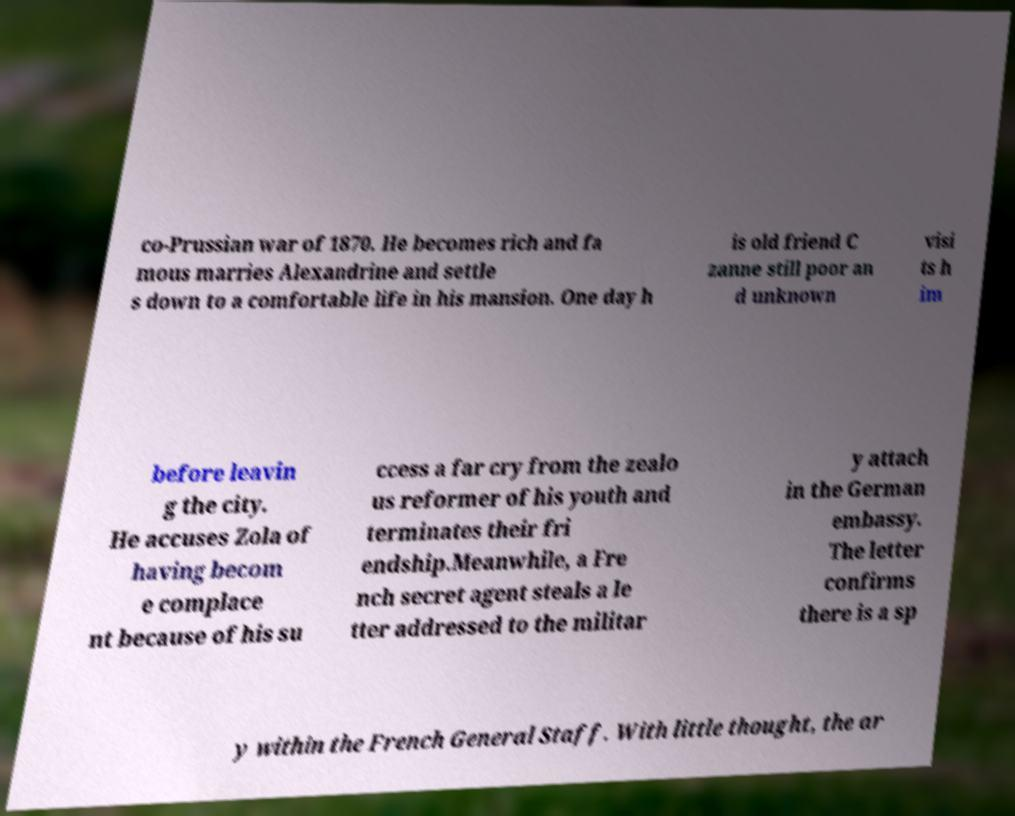Can you read and provide the text displayed in the image?This photo seems to have some interesting text. Can you extract and type it out for me? co-Prussian war of 1870. He becomes rich and fa mous marries Alexandrine and settle s down to a comfortable life in his mansion. One day h is old friend C zanne still poor an d unknown visi ts h im before leavin g the city. He accuses Zola of having becom e complace nt because of his su ccess a far cry from the zealo us reformer of his youth and terminates their fri endship.Meanwhile, a Fre nch secret agent steals a le tter addressed to the militar y attach in the German embassy. The letter confirms there is a sp y within the French General Staff. With little thought, the ar 